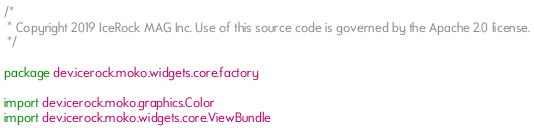<code> <loc_0><loc_0><loc_500><loc_500><_Kotlin_>/*
 * Copyright 2019 IceRock MAG Inc. Use of this source code is governed by the Apache 2.0 license.
 */

package dev.icerock.moko.widgets.core.factory

import dev.icerock.moko.graphics.Color
import dev.icerock.moko.widgets.core.ViewBundle</code> 